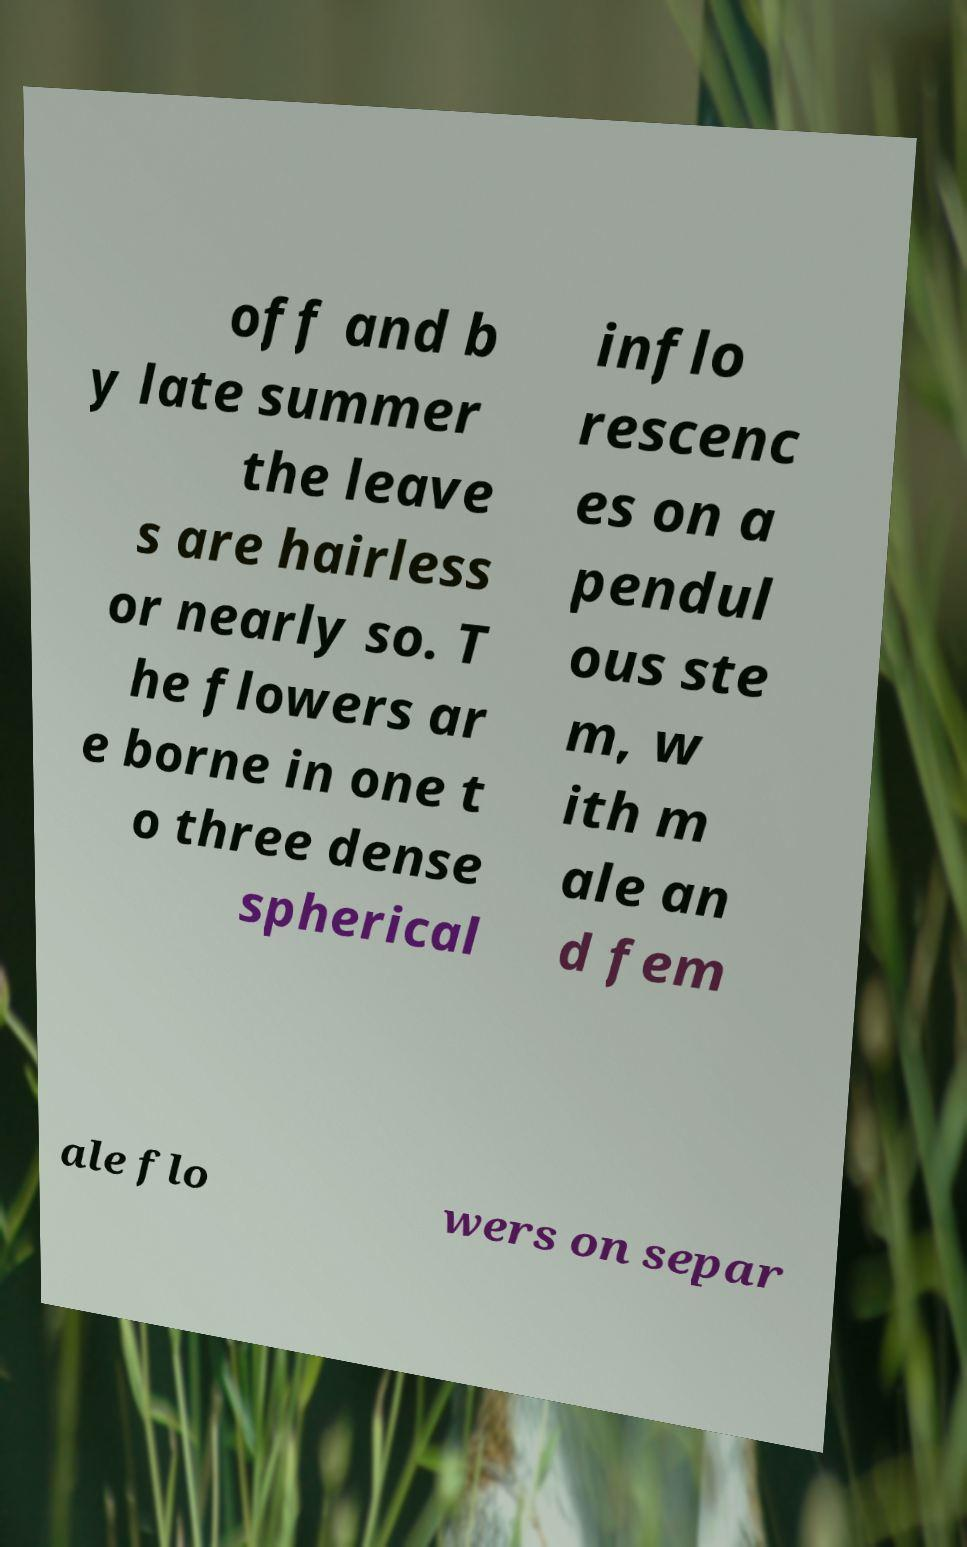Please read and relay the text visible in this image. What does it say? off and b y late summer the leave s are hairless or nearly so. T he flowers ar e borne in one t o three dense spherical inflo rescenc es on a pendul ous ste m, w ith m ale an d fem ale flo wers on separ 